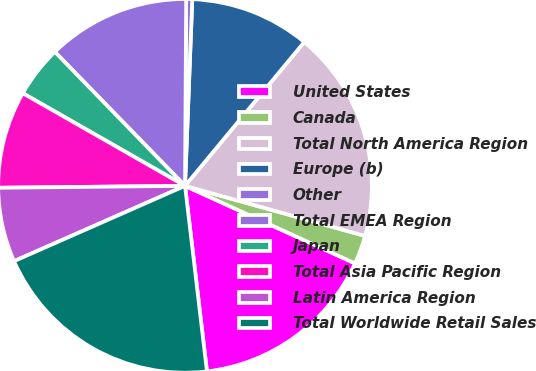Convert chart to OTSL. <chart><loc_0><loc_0><loc_500><loc_500><pie_chart><fcel>United States<fcel>Canada<fcel>Total North America Region<fcel>Europe (b)<fcel>Other<fcel>Total EMEA Region<fcel>Japan<fcel>Total Asia Pacific Region<fcel>Latin America Region<fcel>Total Worldwide Retail Sales<nl><fcel>16.32%<fcel>2.49%<fcel>18.3%<fcel>10.4%<fcel>0.52%<fcel>12.37%<fcel>4.47%<fcel>8.42%<fcel>6.44%<fcel>20.27%<nl></chart> 